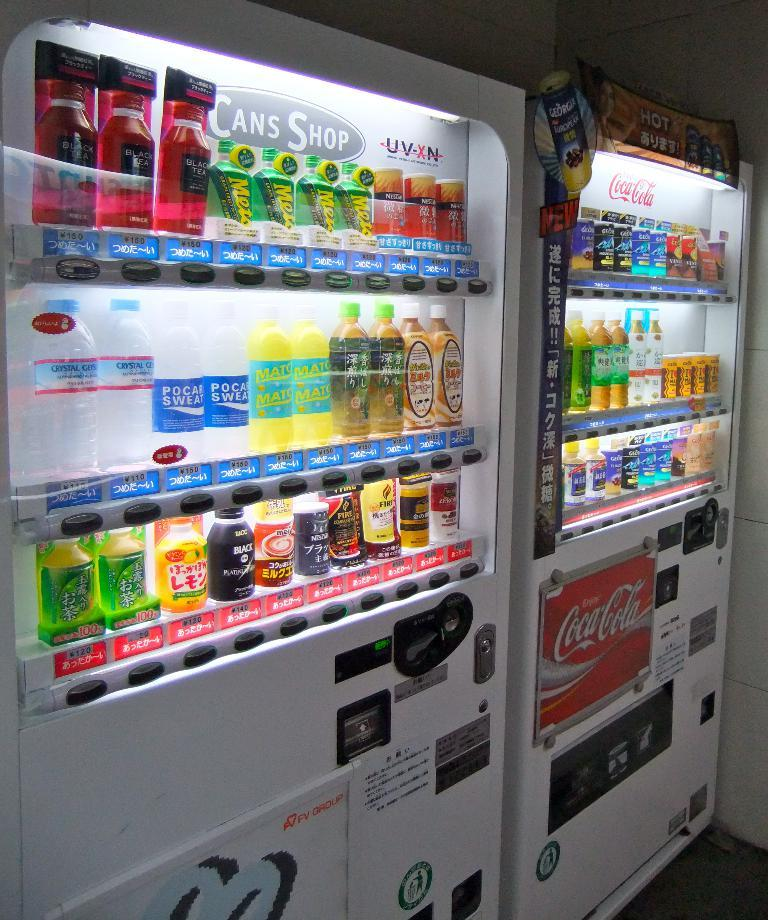Provide a one-sentence caption for the provided image. Two drinking machines from Coca cola that contains drinks. 